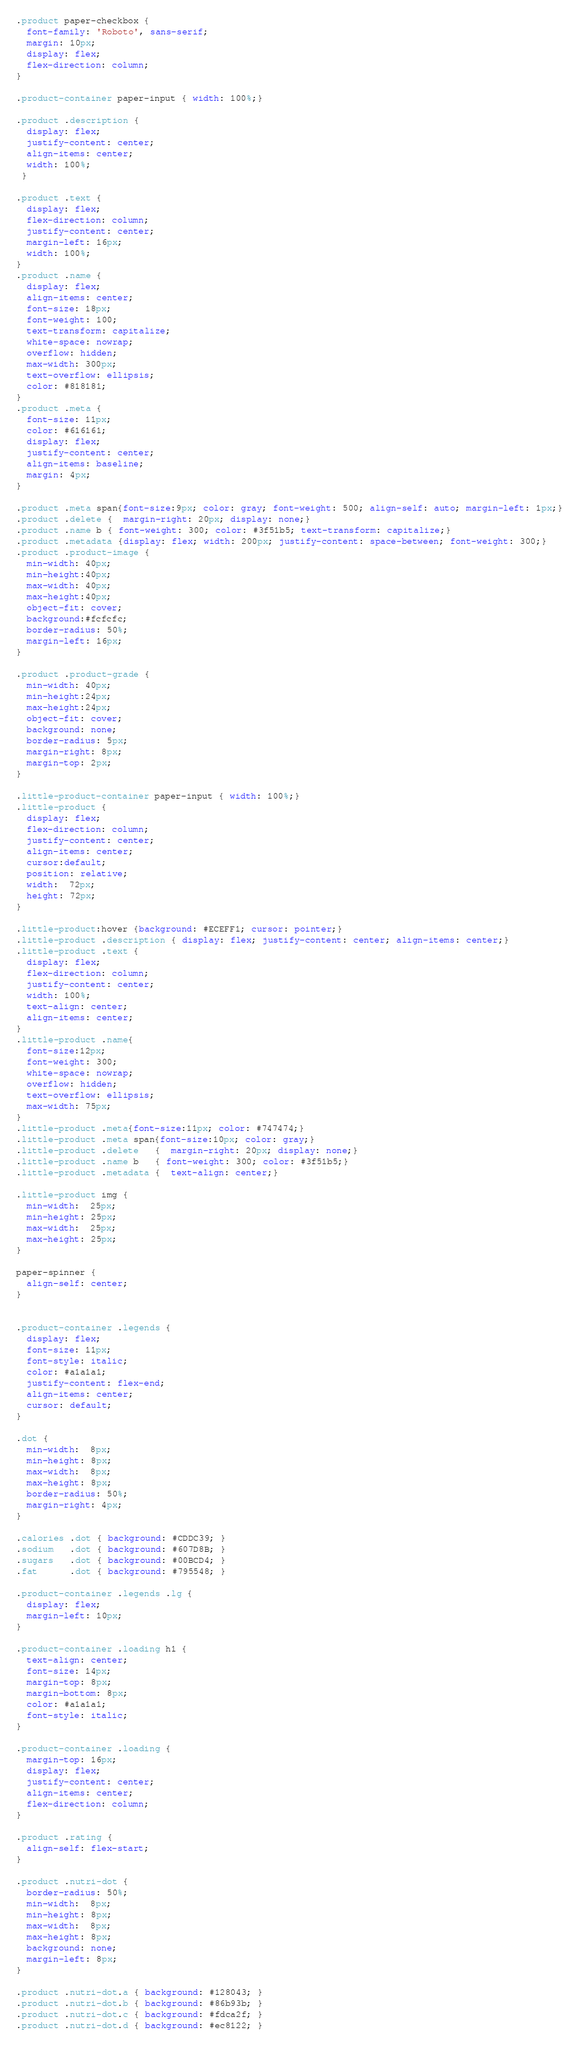<code> <loc_0><loc_0><loc_500><loc_500><_CSS_>.product paper-checkbox {
  font-family: 'Roboto', sans-serif;
  margin: 10px;
  display: flex;
  flex-direction: column;
}

.product-container paper-input { width: 100%;}

.product .description {
  display: flex;
  justify-content: center;
  align-items: center;
  width: 100%;
 }

.product .text {
  display: flex;
  flex-direction: column;
  justify-content: center;
  margin-left: 16px;
  width: 100%;
}
.product .name {
  display: flex;
  align-items: center;
  font-size: 18px;
  font-weight: 100;
  text-transform: capitalize;
  white-space: nowrap;
  overflow: hidden;
  max-width: 300px;
  text-overflow: ellipsis;
  color: #818181;
}
.product .meta {
  font-size: 11px;
  color: #616161;
  display: flex;
  justify-content: center;
  align-items: baseline;
  margin: 4px;
}

.product .meta span{font-size:9px; color: gray; font-weight: 500; align-self: auto; margin-left: 1px;}
.product .delete {  margin-right: 20px; display: none;}
.product .name b { font-weight: 300; color: #3f51b5; text-transform: capitalize;}
.product .metadata {display: flex; width: 200px; justify-content: space-between; font-weight: 300;}
.product .product-image {
  min-width: 40px;
  min-height:40px;
  max-width: 40px;
  max-height:40px;
  object-fit: cover;
  background:#fcfcfc;
  border-radius: 50%;
  margin-left: 16px;
}

.product .product-grade {
  min-width: 40px;
  min-height:24px;
  max-height:24px;
  object-fit: cover;
  background: none;
  border-radius: 5px;
  margin-right: 8px;
  margin-top: 2px;
}

.little-product-container paper-input { width: 100%;}
.little-product {
  display: flex;
  flex-direction: column;
  justify-content: center;
  align-items: center;
  cursor:default;
  position: relative;
  width:  72px;
  height: 72px;
}

.little-product:hover {background: #ECEFF1; cursor: pointer;}
.little-product .description { display: flex; justify-content: center; align-items: center;}
.little-product .text {
  display: flex;
  flex-direction: column;
  justify-content: center;
  width: 100%;
  text-align: center;
  align-items: center;
}
.little-product .name{
  font-size:12px;
  font-weight: 300;
  white-space: nowrap;
  overflow: hidden;
  text-overflow: ellipsis;
  max-width: 75px;
}
.little-product .meta{font-size:11px; color: #747474;}
.little-product .meta span{font-size:10px; color: gray;}
.little-product .delete   {  margin-right: 20px; display: none;}
.little-product .name b   { font-weight: 300; color: #3f51b5;}
.little-product .metadata {  text-align: center;}

.little-product img {
  min-width:  25px;
  min-height: 25px;
  max-width:  25px;
  max-height: 25px;
}

paper-spinner {
  align-self: center;
}


.product-container .legends {
  display: flex;
  font-size: 11px;
  font-style: italic;
  color: #a1a1a1;
  justify-content: flex-end;
  align-items: center;
  cursor: default;
}

.dot {
  min-width:  8px;
  min-height: 8px;
  max-width:  8px;
  max-height: 8px;
  border-radius: 50%;
  margin-right: 4px;
}

.calories .dot { background: #CDDC39; }
.sodium   .dot { background: #607D8B; }
.sugars   .dot { background: #00BCD4; }
.fat      .dot { background: #795548; }

.product-container .legends .lg {
  display: flex;
  margin-left: 10px;
}

.product-container .loading h1 {
  text-align: center;
  font-size: 14px;
  margin-top: 8px;
  margin-bottom: 8px;
  color: #a1a1a1;
  font-style: italic;
}

.product-container .loading {
  margin-top: 16px;
  display: flex;
  justify-content: center;
  align-items: center;
  flex-direction: column;
}

.product .rating {
  align-self: flex-start;
}

.product .nutri-dot {
  border-radius: 50%;
  min-width:  8px;
  min-height: 8px;
  max-width:  8px;
  max-height: 8px;
  background: none;
  margin-left: 8px;
}

.product .nutri-dot.a { background: #128043; }
.product .nutri-dot.b { background: #86b93b; }
.product .nutri-dot.c { background: #fdca2f; }
.product .nutri-dot.d { background: #ec8122; }</code> 